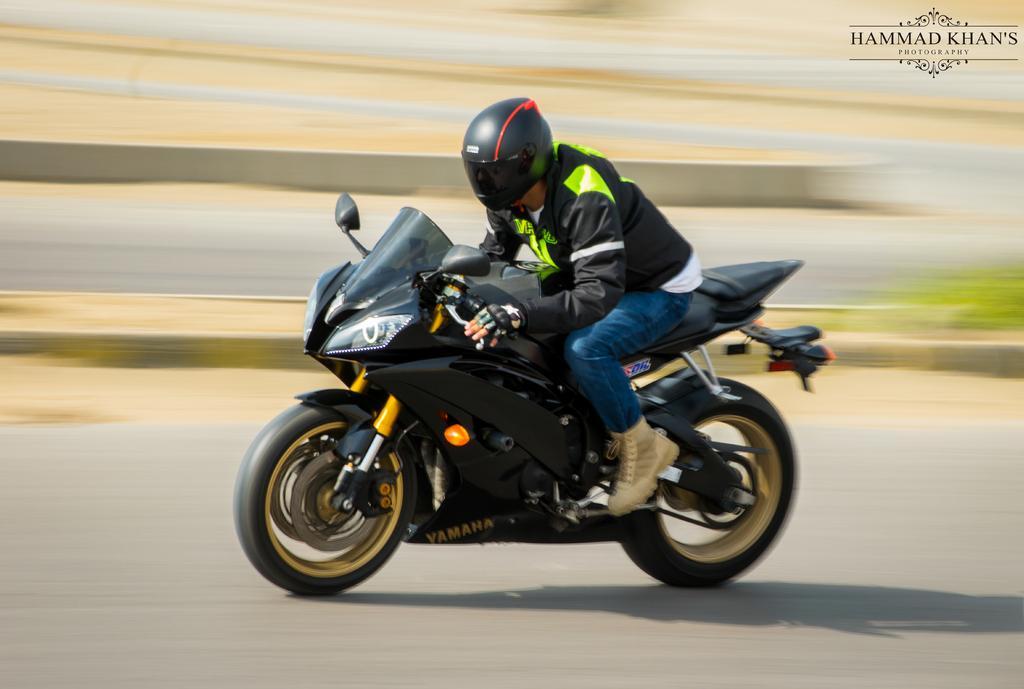Could you give a brief overview of what you see in this image? In the picture there is a man riding a bike and the picture is captured while the bike is in motion. 